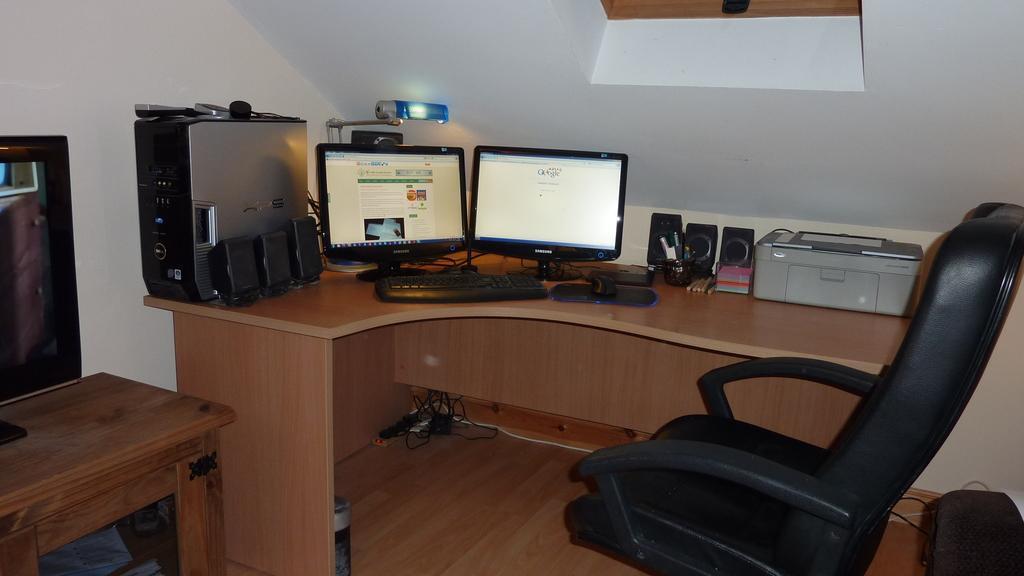Can you describe this image briefly? In this picture there is a table which has two desktops,keyboard,mouse,printer,speakers and some other objects on it and there is a chair in the right corner and there is another table which has a television placed on it in the right corner. 